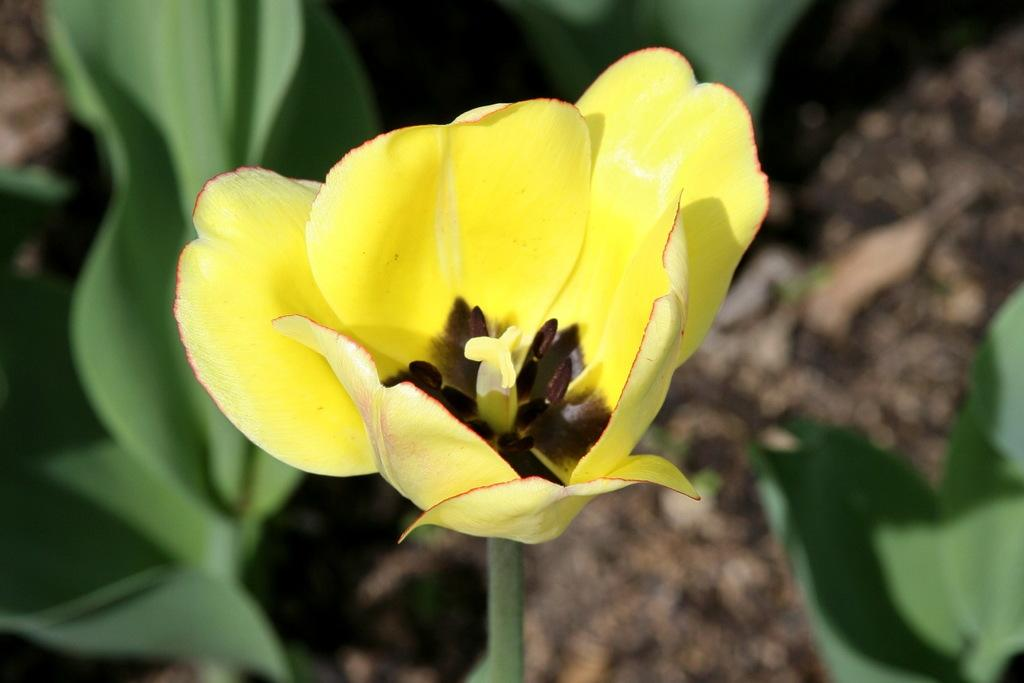What is the main subject of the image? There is a flower in the image. Can you describe the colors of the flower? The flower has yellow, red, and black colors. How would you describe the background of the image? The background of the image is blurred. What type of cabbage is sitting on the sofa in the image? There is no cabbage or sofa present in the image; it features a flower with specific colors and a blurred background. 